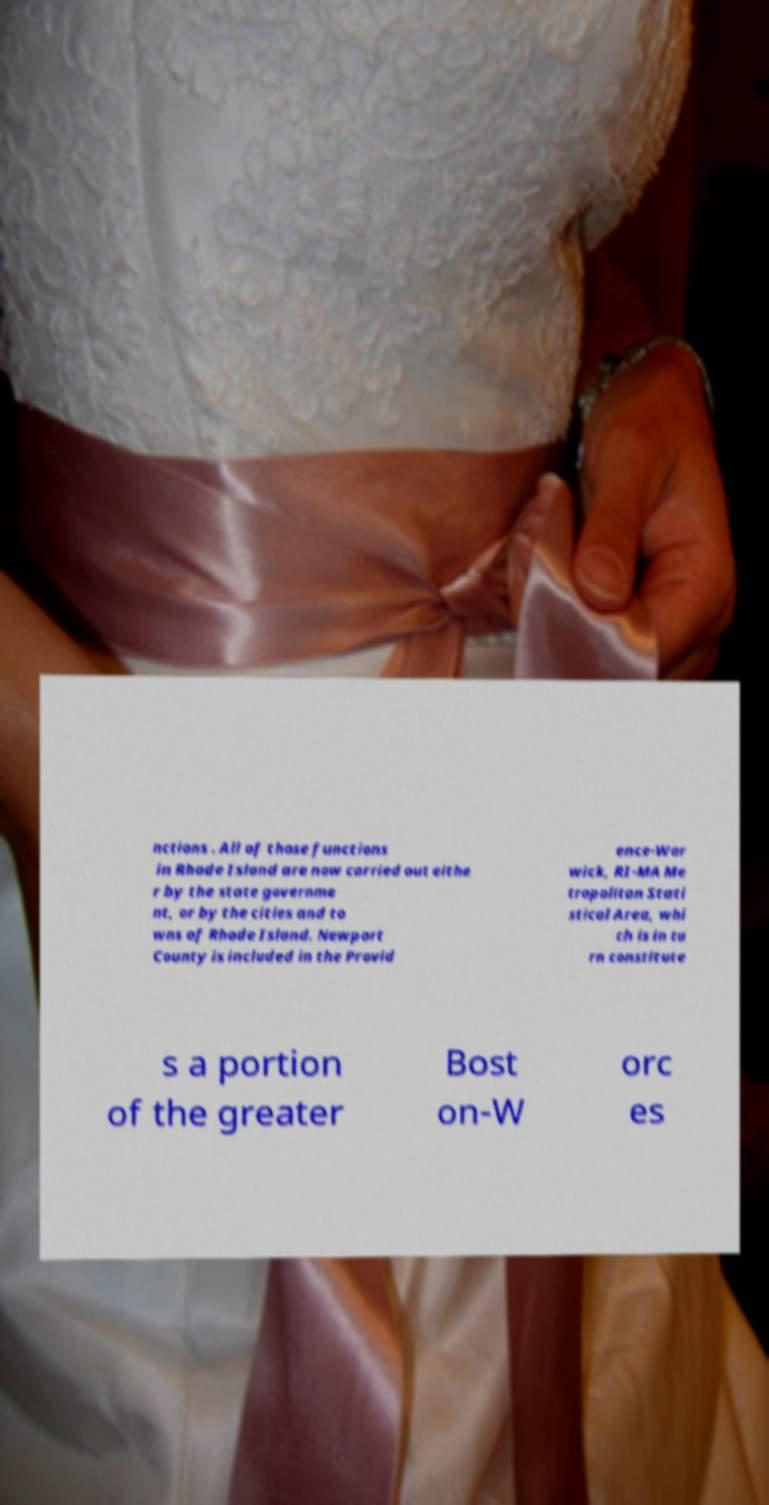For documentation purposes, I need the text within this image transcribed. Could you provide that? nctions . All of those functions in Rhode Island are now carried out eithe r by the state governme nt, or by the cities and to wns of Rhode Island. Newport County is included in the Provid ence-War wick, RI-MA Me tropolitan Stati stical Area, whi ch is in tu rn constitute s a portion of the greater Bost on-W orc es 